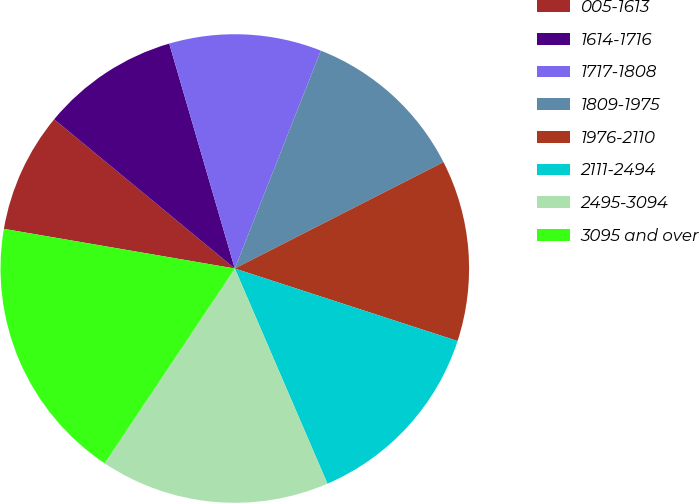<chart> <loc_0><loc_0><loc_500><loc_500><pie_chart><fcel>005-1613<fcel>1614-1716<fcel>1717-1808<fcel>1809-1975<fcel>1976-2110<fcel>2111-2494<fcel>2495-3094<fcel>3095 and over<nl><fcel>8.28%<fcel>9.5%<fcel>10.5%<fcel>11.51%<fcel>12.51%<fcel>13.52%<fcel>15.85%<fcel>18.33%<nl></chart> 